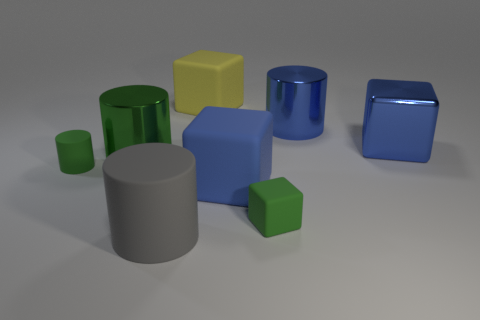There is a blue cylinder that is the same size as the gray cylinder; what material is it?
Provide a short and direct response. Metal. There is a matte thing that is to the left of the big green object; is its shape the same as the gray matte thing in front of the green metal cylinder?
Give a very brief answer. Yes. There is another tiny object that is the same shape as the gray matte object; what is its material?
Your answer should be very brief. Rubber. The blue matte object is what shape?
Make the answer very short. Cube. How many gray matte things have the same shape as the big green thing?
Your answer should be very brief. 1. Is the number of yellow matte cubes that are to the left of the gray thing less than the number of large cubes behind the yellow cube?
Offer a very short reply. No. What number of gray matte cylinders are behind the large matte block that is behind the tiny matte cylinder?
Offer a terse response. 0. Are any red shiny spheres visible?
Provide a short and direct response. No. Is there a cyan cylinder made of the same material as the tiny block?
Ensure brevity in your answer.  No. Are there more large gray matte cylinders that are in front of the yellow thing than big things that are on the left side of the gray cylinder?
Keep it short and to the point. No. 